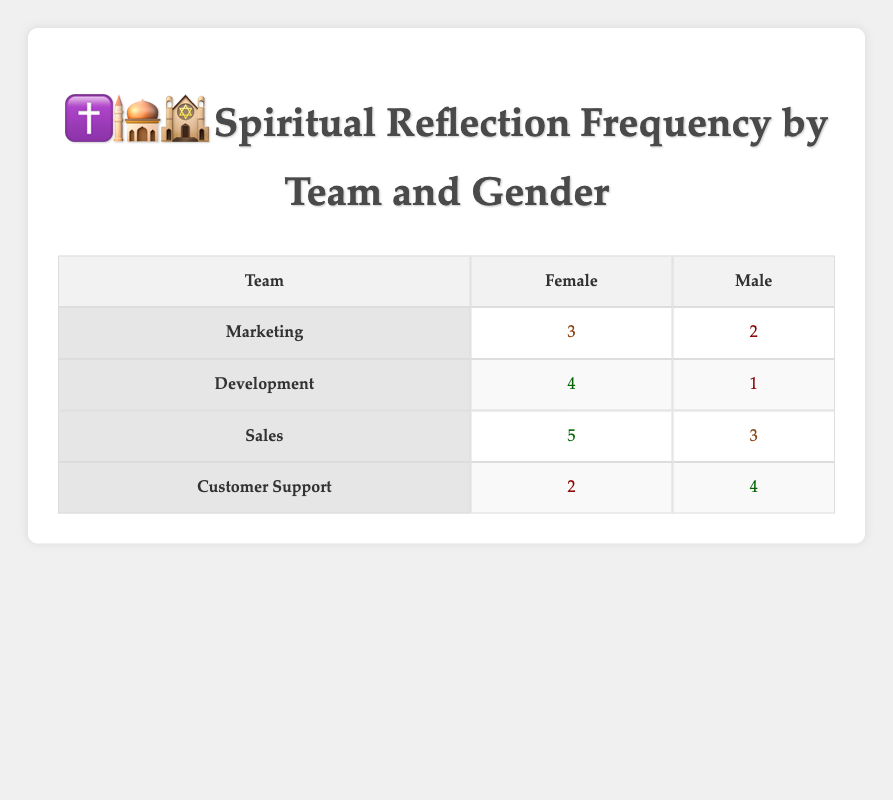What is the spiritual reflection frequency for the Development team's female members? The table shows that the reflection frequency for female members in the Development team is listed under the "Female" column for Development, which indicates a frequency of 4.
Answer: 4 Which team has the highest spiritual reflection frequency for male members? By comparing the reflection frequencies of males across the teams, the Sales team has the highest frequency, showing a value of 3.
Answer: Sales What is the total spiritual reflection frequency for all female members across all teams? To find the total for female members, we sum the frequencies: 3 (Marketing) + 4 (Development) + 5 (Sales) + 2 (Customer Support) = 14.
Answer: 14 Do male members in the Customer Support team have a higher spiritual reflection frequency than those in the Development team? The frequency for male members in Customer Support is 4, while in Development, it is only 1. Therefore, 4 is greater than 1, indicating that males in Customer Support have a higher reflection frequency.
Answer: Yes What is the average spiritual reflection frequency for female members across all teams? To calculate the average for females: (3 + 4 + 5 + 2) = 14, and divide by the number of teams, which is 4. Therefore, 14 / 4 = 3.5.
Answer: 3.5 Which gender has a higher average spiritual reflection frequency across all teams? First, we find the averages: Female total is 14 (3 for Marketing, 4 for Development, 5 for Sales, 2 for Customer Support) summed and divided by 4 results in 3.5. For males: total is 2 + 1 + 3 + 4 = 10, divided by 4 gives us 2.5. Since 3.5 > 2.5, females have a higher average.
Answer: Female What is the difference in spiritual reflection frequency between the highest and lowest values for male members? The highest frequency for male members is 4 (Customer Support), and the lowest is 1 (Development). The difference is calculated as 4 - 1 = 3.
Answer: 3 Is it true that all teams have a spiritual reflection frequency greater than 1 for female members? Looking at the frequency, Marketing has 3, Development has 4, Sales has 5, and Customer Support has 2. All values exceed 1, confirming the statement as true.
Answer: Yes 